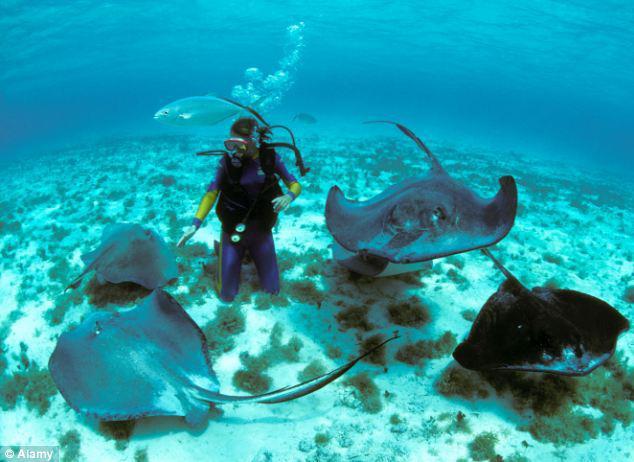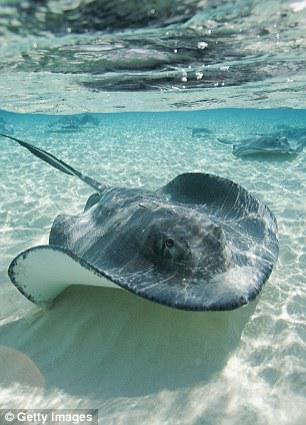The first image is the image on the left, the second image is the image on the right. For the images displayed, is the sentence "The sting ray in the right picture is facing towards the left." factually correct? Answer yes or no. No. The first image is the image on the left, the second image is the image on the right. Considering the images on both sides, is "All of the stingrays are near the ocean floor." valid? Answer yes or no. Yes. 